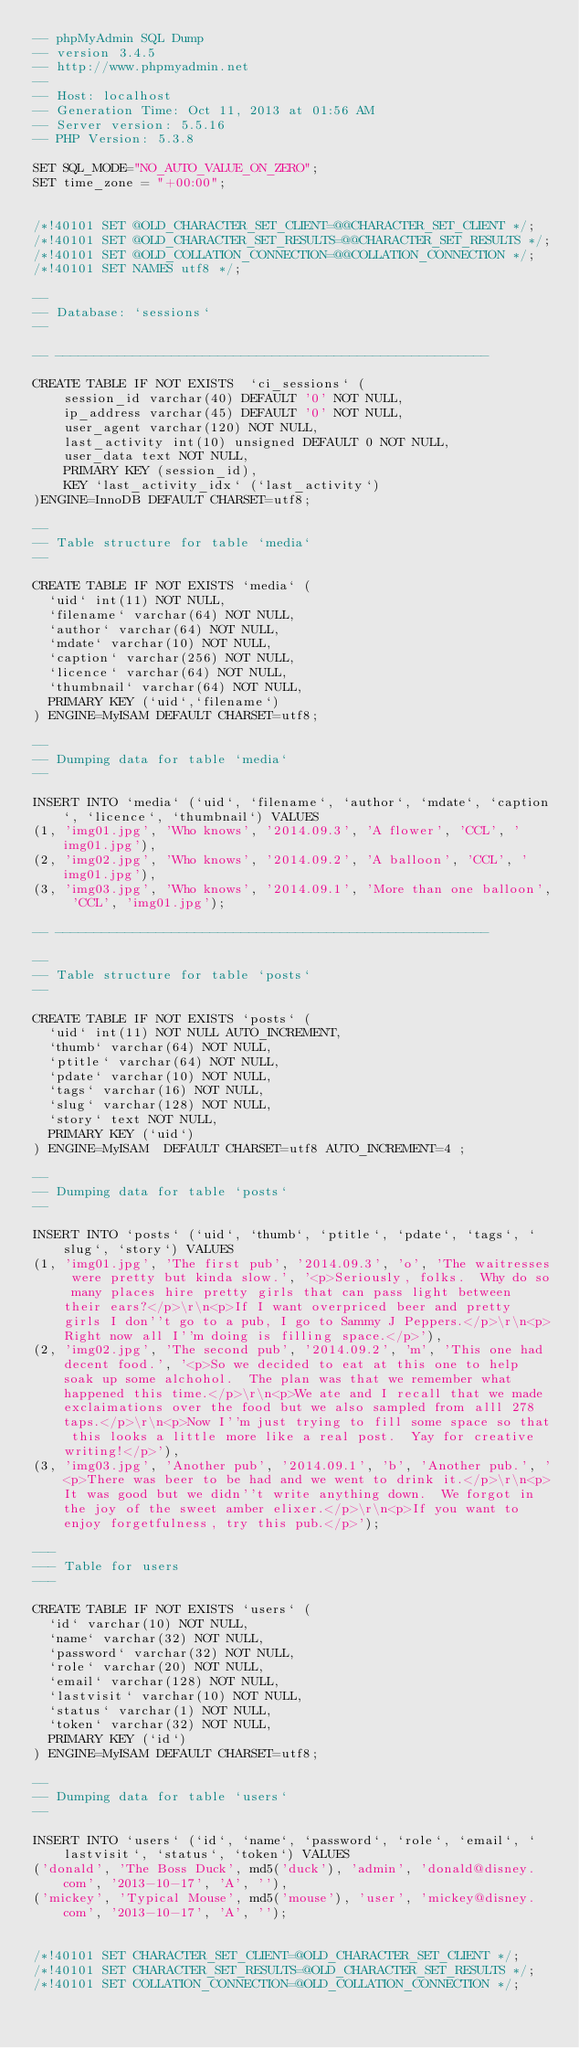Convert code to text. <code><loc_0><loc_0><loc_500><loc_500><_SQL_>-- phpMyAdmin SQL Dump
-- version 3.4.5
-- http://www.phpmyadmin.net
--
-- Host: localhost
-- Generation Time: Oct 11, 2013 at 01:56 AM
-- Server version: 5.5.16
-- PHP Version: 5.3.8

SET SQL_MODE="NO_AUTO_VALUE_ON_ZERO";
SET time_zone = "+00:00";


/*!40101 SET @OLD_CHARACTER_SET_CLIENT=@@CHARACTER_SET_CLIENT */;
/*!40101 SET @OLD_CHARACTER_SET_RESULTS=@@CHARACTER_SET_RESULTS */;
/*!40101 SET @OLD_COLLATION_CONNECTION=@@COLLATION_CONNECTION */;
/*!40101 SET NAMES utf8 */;

--
-- Database: `sessions`
--

-- --------------------------------------------------------

CREATE TABLE IF NOT EXISTS  `ci_sessions` (
	session_id varchar(40) DEFAULT '0' NOT NULL,
	ip_address varchar(45) DEFAULT '0' NOT NULL,
	user_agent varchar(120) NOT NULL,
	last_activity int(10) unsigned DEFAULT 0 NOT NULL,
	user_data text NOT NULL,
	PRIMARY KEY (session_id),
	KEY `last_activity_idx` (`last_activity`)
)ENGINE=InnoDB DEFAULT CHARSET=utf8;

--
-- Table structure for table `media`
--

CREATE TABLE IF NOT EXISTS `media` (
  `uid` int(11) NOT NULL,
  `filename` varchar(64) NOT NULL,
  `author` varchar(64) NOT NULL,
  `mdate` varchar(10) NOT NULL,
  `caption` varchar(256) NOT NULL,
  `licence` varchar(64) NOT NULL,
  `thumbnail` varchar(64) NOT NULL,
  PRIMARY KEY (`uid`,`filename`)
) ENGINE=MyISAM DEFAULT CHARSET=utf8;

--
-- Dumping data for table `media`
--

INSERT INTO `media` (`uid`, `filename`, `author`, `mdate`, `caption`, `licence`, `thumbnail`) VALUES
(1, 'img01.jpg', 'Who knows', '2014.09.3', 'A flower', 'CCL', 'img01.jpg'),
(2, 'img02.jpg', 'Who knows', '2014.09.2', 'A balloon', 'CCL', 'img01.jpg'),
(3, 'img03.jpg', 'Who knows', '2014.09.1', 'More than one balloon', 'CCL', 'img01.jpg');

-- --------------------------------------------------------

--
-- Table structure for table `posts`
--

CREATE TABLE IF NOT EXISTS `posts` (
  `uid` int(11) NOT NULL AUTO_INCREMENT,
  `thumb` varchar(64) NOT NULL,
  `ptitle` varchar(64) NOT NULL,
  `pdate` varchar(10) NOT NULL,
  `tags` varchar(16) NOT NULL,
  `slug` varchar(128) NOT NULL,
  `story` text NOT NULL,
  PRIMARY KEY (`uid`)
) ENGINE=MyISAM  DEFAULT CHARSET=utf8 AUTO_INCREMENT=4 ;

--
-- Dumping data for table `posts`
--

INSERT INTO `posts` (`uid`, `thumb`, `ptitle`, `pdate`, `tags`, `slug`, `story`) VALUES
(1, 'img01.jpg', 'The first pub', '2014.09.3', 'o', 'The waitresses were pretty but kinda slow.', '<p>Seriously, folks.  Why do so many places hire pretty girls that can pass light between their ears?</p>\r\n<p>If I want overpriced beer and pretty girls I don''t go to a pub, I go to Sammy J Peppers.</p>\r\n<p>Right now all I''m doing is filling space.</p>'),
(2, 'img02.jpg', 'The second pub', '2014.09.2', 'm', 'This one had decent food.', '<p>So we decided to eat at this one to help soak up some alchohol.  The plan was that we remember what happened this time.</p>\r\n<p>We ate and I recall that we made exclaimations over the food but we also sampled from alll 278 taps.</p>\r\n<p>Now I''m just trying to fill some space so that this looks a little more like a real post.  Yay for creative writing!</p>'),
(3, 'img03.jpg', 'Another pub', '2014.09.1', 'b', 'Another pub.', '<p>There was beer to be had and we went to drink it.</p>\r\n<p>It was good but we didn''t write anything down.  We forgot in the joy of the sweet amber elixer.</p>\r\n<p>If you want to enjoy forgetfulness, try this pub.</p>');

---
--- Table for users
---

CREATE TABLE IF NOT EXISTS `users` (
  `id` varchar(10) NOT NULL,
  `name` varchar(32) NOT NULL,
  `password` varchar(32) NOT NULL,
  `role` varchar(20) NOT NULL,
  `email` varchar(128) NOT NULL,
  `lastvisit` varchar(10) NOT NULL,
  `status` varchar(1) NOT NULL,
  `token` varchar(32) NOT NULL,
  PRIMARY KEY (`id`)
) ENGINE=MyISAM DEFAULT CHARSET=utf8;

--
-- Dumping data for table `users`
--

INSERT INTO `users` (`id`, `name`, `password`, `role`, `email`, `lastvisit`, `status`, `token`) VALUES
('donald', 'The Boss Duck', md5('duck'), 'admin', 'donald@disney.com', '2013-10-17', 'A', ''),
('mickey', 'Typical Mouse', md5('mouse'), 'user', 'mickey@disney.com', '2013-10-17', 'A', '');


/*!40101 SET CHARACTER_SET_CLIENT=@OLD_CHARACTER_SET_CLIENT */;
/*!40101 SET CHARACTER_SET_RESULTS=@OLD_CHARACTER_SET_RESULTS */;
/*!40101 SET COLLATION_CONNECTION=@OLD_COLLATION_CONNECTION */;
</code> 